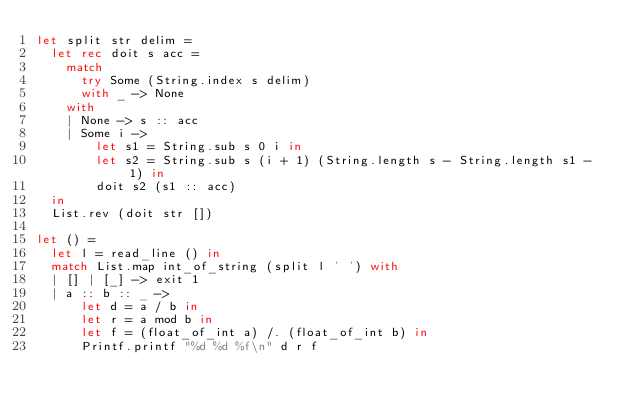Convert code to text. <code><loc_0><loc_0><loc_500><loc_500><_OCaml_>let split str delim =
  let rec doit s acc =
    match
      try Some (String.index s delim)
      with _ -> None
    with
    | None -> s :: acc
    | Some i ->
        let s1 = String.sub s 0 i in
        let s2 = String.sub s (i + 1) (String.length s - String.length s1 - 1) in
        doit s2 (s1 :: acc)
  in
  List.rev (doit str [])

let () =
  let l = read_line () in
  match List.map int_of_string (split l ' ') with
  | [] | [_] -> exit 1
  | a :: b :: _ ->
      let d = a / b in
      let r = a mod b in
      let f = (float_of_int a) /. (float_of_int b) in
      Printf.printf "%d %d %f\n" d r f</code> 